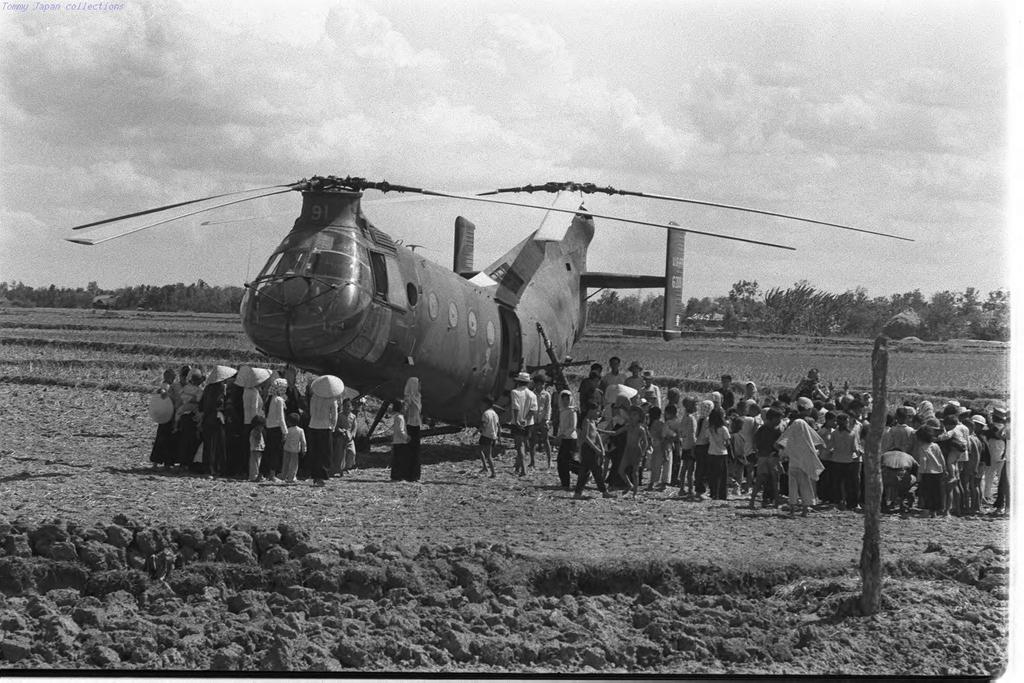How would you summarize this image in a sentence or two? This is a black and white image and here we can see many people and some of them are wearing caps and there is helicopter. In the background, there are trees and we can see poles. At the bottom, there is ground and at the top, there is sky. 